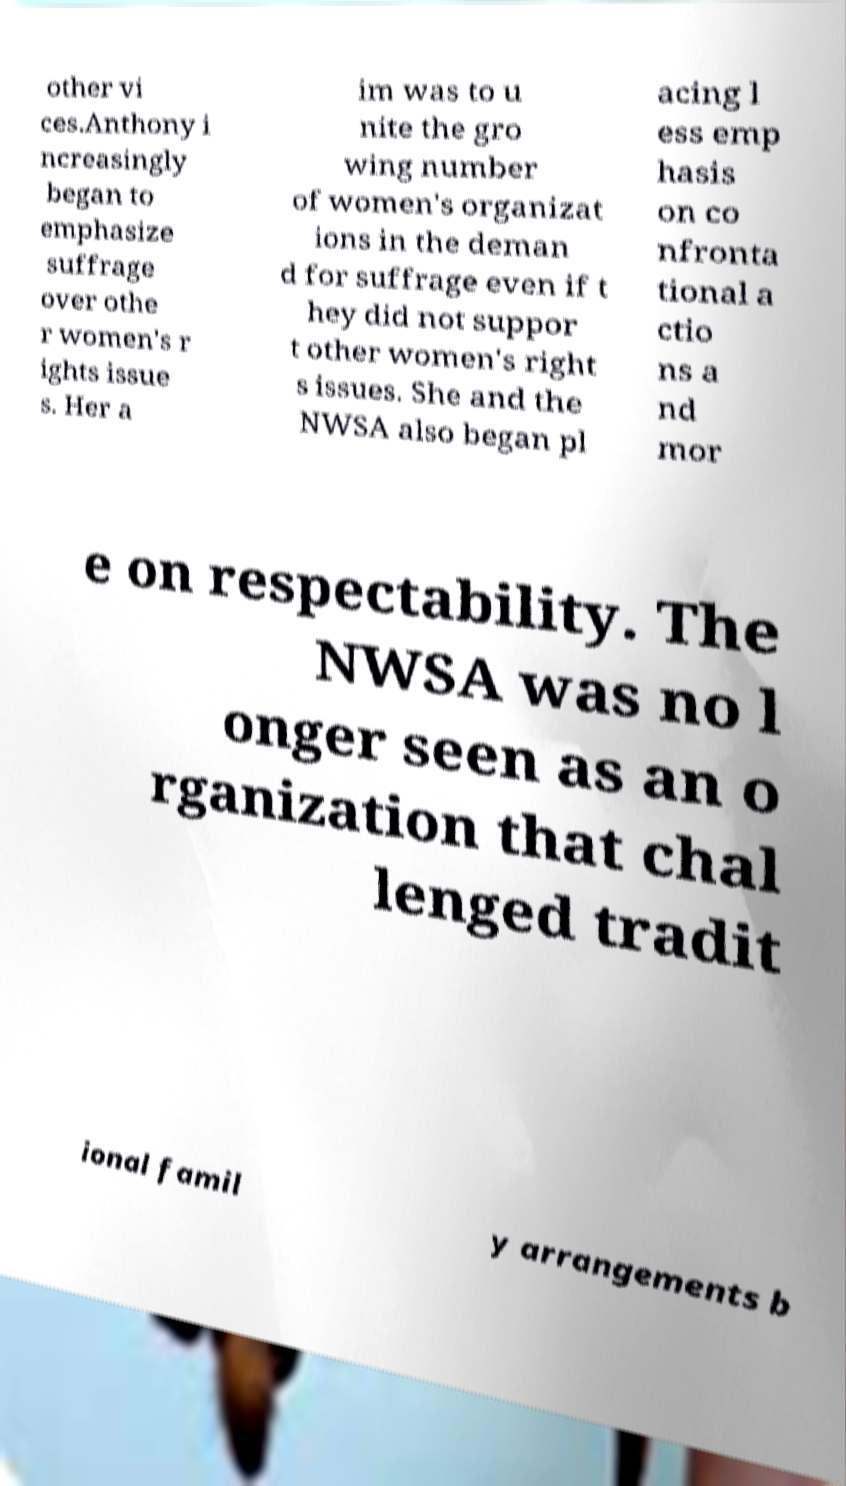Can you accurately transcribe the text from the provided image for me? other vi ces.Anthony i ncreasingly began to emphasize suffrage over othe r women's r ights issue s. Her a im was to u nite the gro wing number of women's organizat ions in the deman d for suffrage even if t hey did not suppor t other women's right s issues. She and the NWSA also began pl acing l ess emp hasis on co nfronta tional a ctio ns a nd mor e on respectability. The NWSA was no l onger seen as an o rganization that chal lenged tradit ional famil y arrangements b 